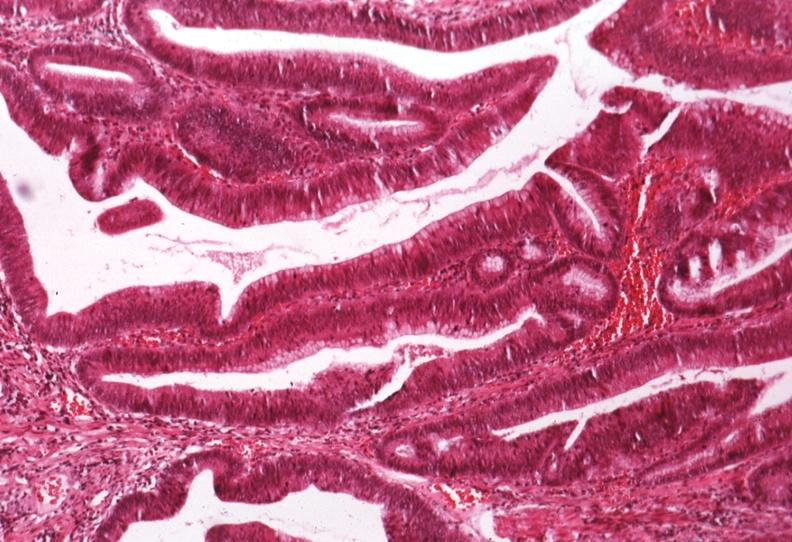s whipples disease present?
Answer the question using a single word or phrase. No 